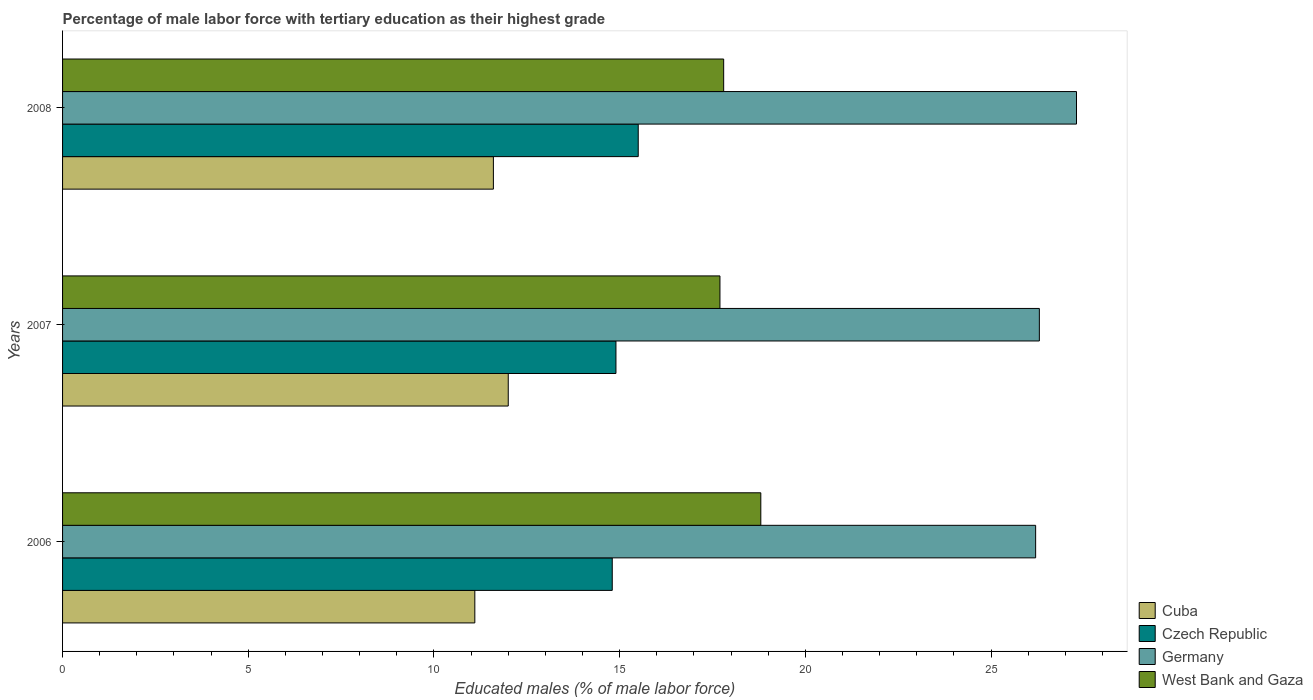How many different coloured bars are there?
Provide a succinct answer. 4. How many groups of bars are there?
Ensure brevity in your answer.  3. What is the label of the 1st group of bars from the top?
Your answer should be very brief. 2008. In how many cases, is the number of bars for a given year not equal to the number of legend labels?
Ensure brevity in your answer.  0. What is the percentage of male labor force with tertiary education in Cuba in 2006?
Give a very brief answer. 11.1. Across all years, what is the maximum percentage of male labor force with tertiary education in Czech Republic?
Keep it short and to the point. 15.5. Across all years, what is the minimum percentage of male labor force with tertiary education in Germany?
Your answer should be very brief. 26.2. In which year was the percentage of male labor force with tertiary education in Germany minimum?
Provide a succinct answer. 2006. What is the total percentage of male labor force with tertiary education in Germany in the graph?
Provide a succinct answer. 79.8. What is the difference between the percentage of male labor force with tertiary education in West Bank and Gaza in 2006 and that in 2007?
Provide a short and direct response. 1.1. What is the difference between the percentage of male labor force with tertiary education in Czech Republic in 2006 and the percentage of male labor force with tertiary education in Cuba in 2008?
Your answer should be compact. 3.2. What is the average percentage of male labor force with tertiary education in West Bank and Gaza per year?
Your answer should be compact. 18.1. In the year 2007, what is the difference between the percentage of male labor force with tertiary education in Cuba and percentage of male labor force with tertiary education in Germany?
Your answer should be very brief. -14.3. In how many years, is the percentage of male labor force with tertiary education in Czech Republic greater than 9 %?
Make the answer very short. 3. What is the ratio of the percentage of male labor force with tertiary education in West Bank and Gaza in 2007 to that in 2008?
Your answer should be compact. 0.99. Is the percentage of male labor force with tertiary education in Germany in 2006 less than that in 2007?
Provide a succinct answer. Yes. What is the difference between the highest and the second highest percentage of male labor force with tertiary education in Cuba?
Give a very brief answer. 0.4. What is the difference between the highest and the lowest percentage of male labor force with tertiary education in West Bank and Gaza?
Your answer should be very brief. 1.1. In how many years, is the percentage of male labor force with tertiary education in Cuba greater than the average percentage of male labor force with tertiary education in Cuba taken over all years?
Ensure brevity in your answer.  2. Is the sum of the percentage of male labor force with tertiary education in Cuba in 2006 and 2008 greater than the maximum percentage of male labor force with tertiary education in West Bank and Gaza across all years?
Keep it short and to the point. Yes. What does the 3rd bar from the top in 2006 represents?
Your answer should be compact. Czech Republic. What does the 4th bar from the bottom in 2006 represents?
Offer a very short reply. West Bank and Gaza. What is the difference between two consecutive major ticks on the X-axis?
Ensure brevity in your answer.  5. Are the values on the major ticks of X-axis written in scientific E-notation?
Make the answer very short. No. Does the graph contain any zero values?
Your answer should be very brief. No. What is the title of the graph?
Give a very brief answer. Percentage of male labor force with tertiary education as their highest grade. Does "Canada" appear as one of the legend labels in the graph?
Your answer should be very brief. No. What is the label or title of the X-axis?
Provide a succinct answer. Educated males (% of male labor force). What is the label or title of the Y-axis?
Offer a terse response. Years. What is the Educated males (% of male labor force) in Cuba in 2006?
Provide a short and direct response. 11.1. What is the Educated males (% of male labor force) in Czech Republic in 2006?
Your answer should be compact. 14.8. What is the Educated males (% of male labor force) in Germany in 2006?
Your response must be concise. 26.2. What is the Educated males (% of male labor force) of West Bank and Gaza in 2006?
Offer a terse response. 18.8. What is the Educated males (% of male labor force) of Czech Republic in 2007?
Your answer should be compact. 14.9. What is the Educated males (% of male labor force) in Germany in 2007?
Offer a very short reply. 26.3. What is the Educated males (% of male labor force) in West Bank and Gaza in 2007?
Your response must be concise. 17.7. What is the Educated males (% of male labor force) in Cuba in 2008?
Give a very brief answer. 11.6. What is the Educated males (% of male labor force) of Czech Republic in 2008?
Make the answer very short. 15.5. What is the Educated males (% of male labor force) of Germany in 2008?
Your response must be concise. 27.3. What is the Educated males (% of male labor force) in West Bank and Gaza in 2008?
Provide a succinct answer. 17.8. Across all years, what is the maximum Educated males (% of male labor force) of Czech Republic?
Make the answer very short. 15.5. Across all years, what is the maximum Educated males (% of male labor force) of Germany?
Offer a terse response. 27.3. Across all years, what is the maximum Educated males (% of male labor force) in West Bank and Gaza?
Your response must be concise. 18.8. Across all years, what is the minimum Educated males (% of male labor force) of Cuba?
Ensure brevity in your answer.  11.1. Across all years, what is the minimum Educated males (% of male labor force) of Czech Republic?
Offer a very short reply. 14.8. Across all years, what is the minimum Educated males (% of male labor force) in Germany?
Your response must be concise. 26.2. Across all years, what is the minimum Educated males (% of male labor force) of West Bank and Gaza?
Your response must be concise. 17.7. What is the total Educated males (% of male labor force) in Cuba in the graph?
Your response must be concise. 34.7. What is the total Educated males (% of male labor force) of Czech Republic in the graph?
Provide a succinct answer. 45.2. What is the total Educated males (% of male labor force) in Germany in the graph?
Make the answer very short. 79.8. What is the total Educated males (% of male labor force) in West Bank and Gaza in the graph?
Offer a terse response. 54.3. What is the difference between the Educated males (% of male labor force) in Cuba in 2006 and that in 2007?
Make the answer very short. -0.9. What is the difference between the Educated males (% of male labor force) of Czech Republic in 2006 and that in 2007?
Your answer should be compact. -0.1. What is the difference between the Educated males (% of male labor force) in West Bank and Gaza in 2006 and that in 2007?
Offer a very short reply. 1.1. What is the difference between the Educated males (% of male labor force) in Czech Republic in 2006 and that in 2008?
Give a very brief answer. -0.7. What is the difference between the Educated males (% of male labor force) of West Bank and Gaza in 2006 and that in 2008?
Offer a very short reply. 1. What is the difference between the Educated males (% of male labor force) in Germany in 2007 and that in 2008?
Ensure brevity in your answer.  -1. What is the difference between the Educated males (% of male labor force) of Cuba in 2006 and the Educated males (% of male labor force) of Czech Republic in 2007?
Provide a short and direct response. -3.8. What is the difference between the Educated males (% of male labor force) of Cuba in 2006 and the Educated males (% of male labor force) of Germany in 2007?
Offer a very short reply. -15.2. What is the difference between the Educated males (% of male labor force) of Czech Republic in 2006 and the Educated males (% of male labor force) of Germany in 2007?
Your answer should be very brief. -11.5. What is the difference between the Educated males (% of male labor force) in Czech Republic in 2006 and the Educated males (% of male labor force) in West Bank and Gaza in 2007?
Ensure brevity in your answer.  -2.9. What is the difference between the Educated males (% of male labor force) in Germany in 2006 and the Educated males (% of male labor force) in West Bank and Gaza in 2007?
Make the answer very short. 8.5. What is the difference between the Educated males (% of male labor force) in Cuba in 2006 and the Educated males (% of male labor force) in Czech Republic in 2008?
Give a very brief answer. -4.4. What is the difference between the Educated males (% of male labor force) in Cuba in 2006 and the Educated males (% of male labor force) in Germany in 2008?
Keep it short and to the point. -16.2. What is the difference between the Educated males (% of male labor force) of Germany in 2006 and the Educated males (% of male labor force) of West Bank and Gaza in 2008?
Give a very brief answer. 8.4. What is the difference between the Educated males (% of male labor force) in Cuba in 2007 and the Educated males (% of male labor force) in Czech Republic in 2008?
Offer a terse response. -3.5. What is the difference between the Educated males (% of male labor force) in Cuba in 2007 and the Educated males (% of male labor force) in Germany in 2008?
Keep it short and to the point. -15.3. What is the difference between the Educated males (% of male labor force) in Czech Republic in 2007 and the Educated males (% of male labor force) in Germany in 2008?
Your answer should be very brief. -12.4. What is the difference between the Educated males (% of male labor force) of Czech Republic in 2007 and the Educated males (% of male labor force) of West Bank and Gaza in 2008?
Offer a very short reply. -2.9. What is the average Educated males (% of male labor force) in Cuba per year?
Ensure brevity in your answer.  11.57. What is the average Educated males (% of male labor force) of Czech Republic per year?
Ensure brevity in your answer.  15.07. What is the average Educated males (% of male labor force) of Germany per year?
Provide a short and direct response. 26.6. What is the average Educated males (% of male labor force) of West Bank and Gaza per year?
Provide a succinct answer. 18.1. In the year 2006, what is the difference between the Educated males (% of male labor force) of Cuba and Educated males (% of male labor force) of Czech Republic?
Your answer should be very brief. -3.7. In the year 2006, what is the difference between the Educated males (% of male labor force) of Cuba and Educated males (% of male labor force) of Germany?
Your response must be concise. -15.1. In the year 2006, what is the difference between the Educated males (% of male labor force) in Cuba and Educated males (% of male labor force) in West Bank and Gaza?
Provide a succinct answer. -7.7. In the year 2006, what is the difference between the Educated males (% of male labor force) in Czech Republic and Educated males (% of male labor force) in Germany?
Your response must be concise. -11.4. In the year 2006, what is the difference between the Educated males (% of male labor force) in Czech Republic and Educated males (% of male labor force) in West Bank and Gaza?
Offer a terse response. -4. In the year 2007, what is the difference between the Educated males (% of male labor force) in Cuba and Educated males (% of male labor force) in Czech Republic?
Ensure brevity in your answer.  -2.9. In the year 2007, what is the difference between the Educated males (% of male labor force) of Cuba and Educated males (% of male labor force) of Germany?
Offer a terse response. -14.3. In the year 2007, what is the difference between the Educated males (% of male labor force) of Czech Republic and Educated males (% of male labor force) of West Bank and Gaza?
Make the answer very short. -2.8. In the year 2007, what is the difference between the Educated males (% of male labor force) of Germany and Educated males (% of male labor force) of West Bank and Gaza?
Your response must be concise. 8.6. In the year 2008, what is the difference between the Educated males (% of male labor force) of Cuba and Educated males (% of male labor force) of Germany?
Provide a succinct answer. -15.7. In the year 2008, what is the difference between the Educated males (% of male labor force) in Czech Republic and Educated males (% of male labor force) in West Bank and Gaza?
Offer a terse response. -2.3. In the year 2008, what is the difference between the Educated males (% of male labor force) of Germany and Educated males (% of male labor force) of West Bank and Gaza?
Give a very brief answer. 9.5. What is the ratio of the Educated males (% of male labor force) in Cuba in 2006 to that in 2007?
Offer a very short reply. 0.93. What is the ratio of the Educated males (% of male labor force) in West Bank and Gaza in 2006 to that in 2007?
Ensure brevity in your answer.  1.06. What is the ratio of the Educated males (% of male labor force) of Cuba in 2006 to that in 2008?
Ensure brevity in your answer.  0.96. What is the ratio of the Educated males (% of male labor force) of Czech Republic in 2006 to that in 2008?
Give a very brief answer. 0.95. What is the ratio of the Educated males (% of male labor force) in Germany in 2006 to that in 2008?
Your response must be concise. 0.96. What is the ratio of the Educated males (% of male labor force) of West Bank and Gaza in 2006 to that in 2008?
Offer a very short reply. 1.06. What is the ratio of the Educated males (% of male labor force) in Cuba in 2007 to that in 2008?
Provide a short and direct response. 1.03. What is the ratio of the Educated males (% of male labor force) of Czech Republic in 2007 to that in 2008?
Your response must be concise. 0.96. What is the ratio of the Educated males (% of male labor force) of Germany in 2007 to that in 2008?
Your answer should be compact. 0.96. What is the ratio of the Educated males (% of male labor force) of West Bank and Gaza in 2007 to that in 2008?
Provide a succinct answer. 0.99. What is the difference between the highest and the second highest Educated males (% of male labor force) of Czech Republic?
Make the answer very short. 0.6. What is the difference between the highest and the second highest Educated males (% of male labor force) in Germany?
Provide a succinct answer. 1. What is the difference between the highest and the second highest Educated males (% of male labor force) in West Bank and Gaza?
Make the answer very short. 1. What is the difference between the highest and the lowest Educated males (% of male labor force) of Czech Republic?
Your answer should be compact. 0.7. What is the difference between the highest and the lowest Educated males (% of male labor force) in West Bank and Gaza?
Provide a short and direct response. 1.1. 